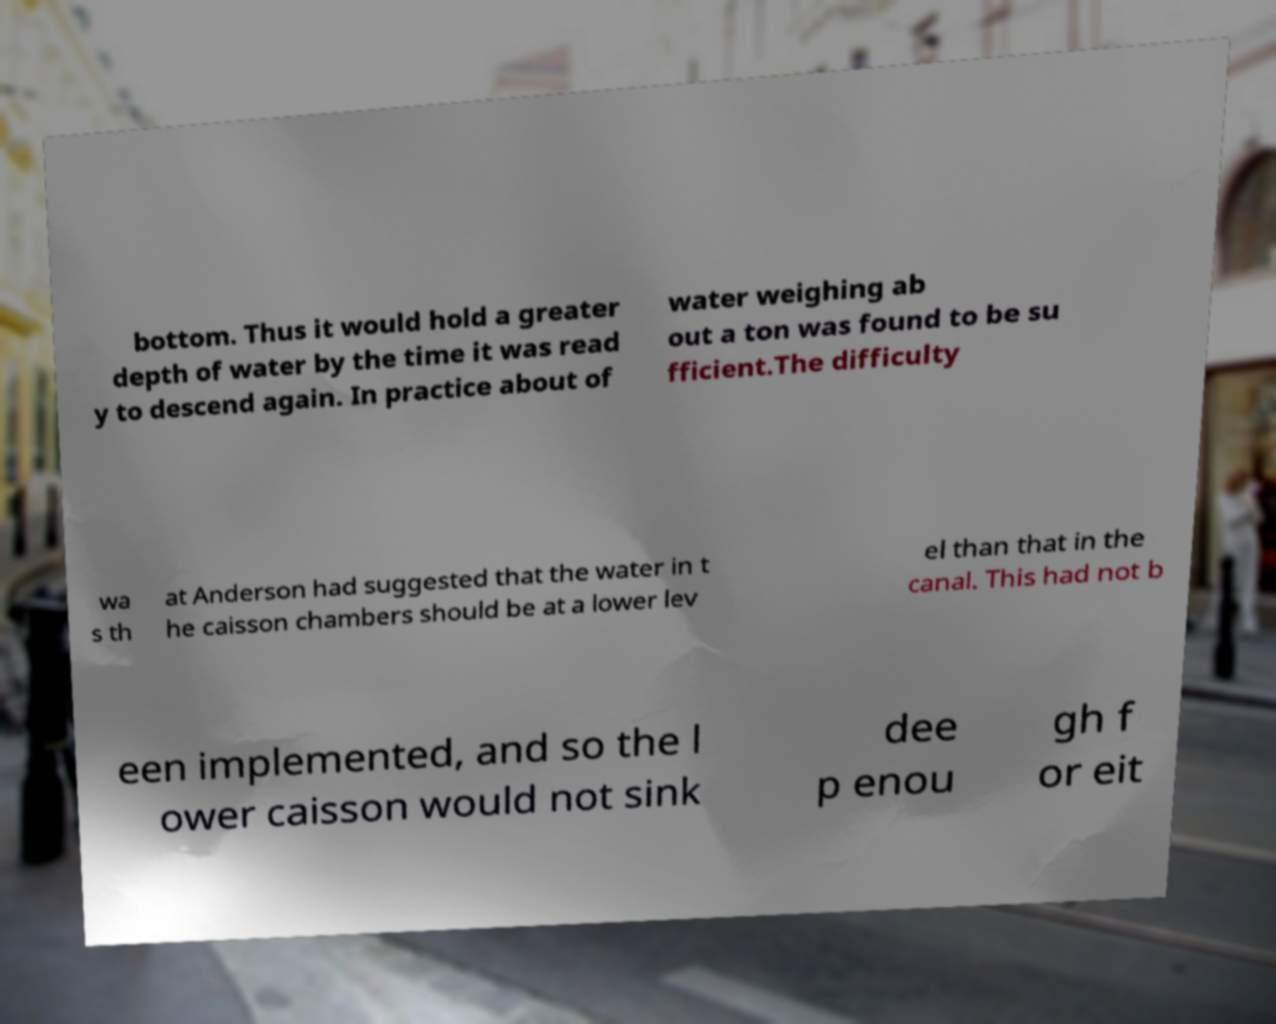What messages or text are displayed in this image? I need them in a readable, typed format. bottom. Thus it would hold a greater depth of water by the time it was read y to descend again. In practice about of water weighing ab out a ton was found to be su fficient.The difficulty wa s th at Anderson had suggested that the water in t he caisson chambers should be at a lower lev el than that in the canal. This had not b een implemented, and so the l ower caisson would not sink dee p enou gh f or eit 